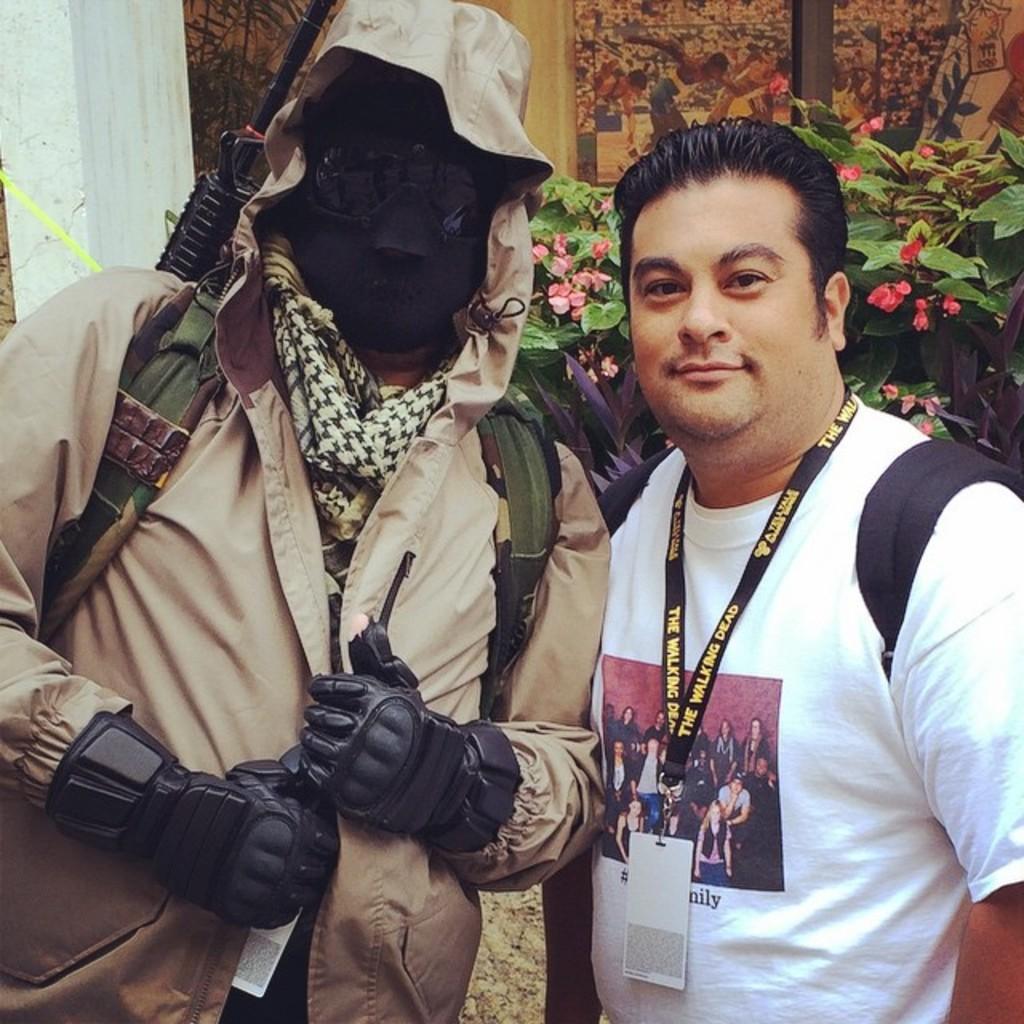Describe this image in one or two sentences. In the image there are two people standing and posing for the photo, the first person is wearing a jacket and he covered his face with a mask and he is also carrying some weapon. Behind the two people there is a plant. 